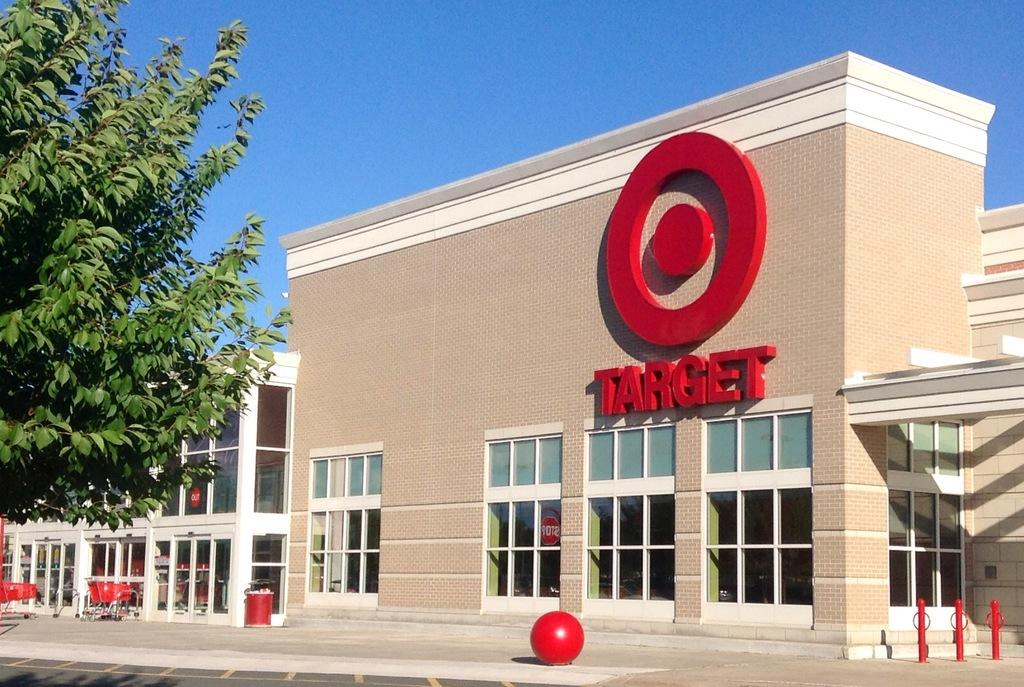What type of structures can be seen in the image? There are buildings in the image. What is located in front of the buildings? Metal rods and carts are present in front of the buildings. What type of plant is visible in the image? There is a tree in the image. What type of faucet can be seen on the tree in the image? There is no faucet present on the tree in the image. 